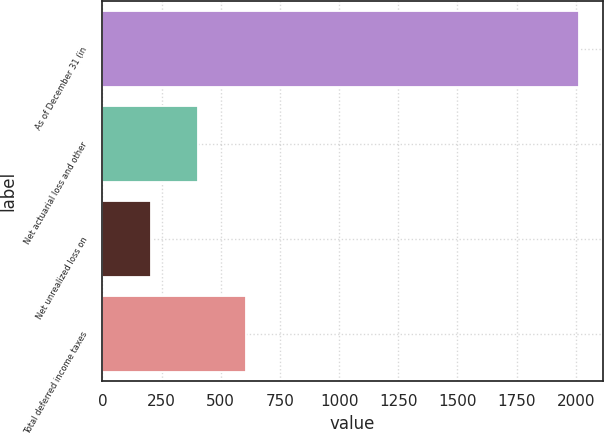Convert chart. <chart><loc_0><loc_0><loc_500><loc_500><bar_chart><fcel>As of December 31 (in<fcel>Net actuarial loss and other<fcel>Net unrealized loss on<fcel>Total deferred income taxes<nl><fcel>2014<fcel>404.56<fcel>203.38<fcel>605.74<nl></chart> 